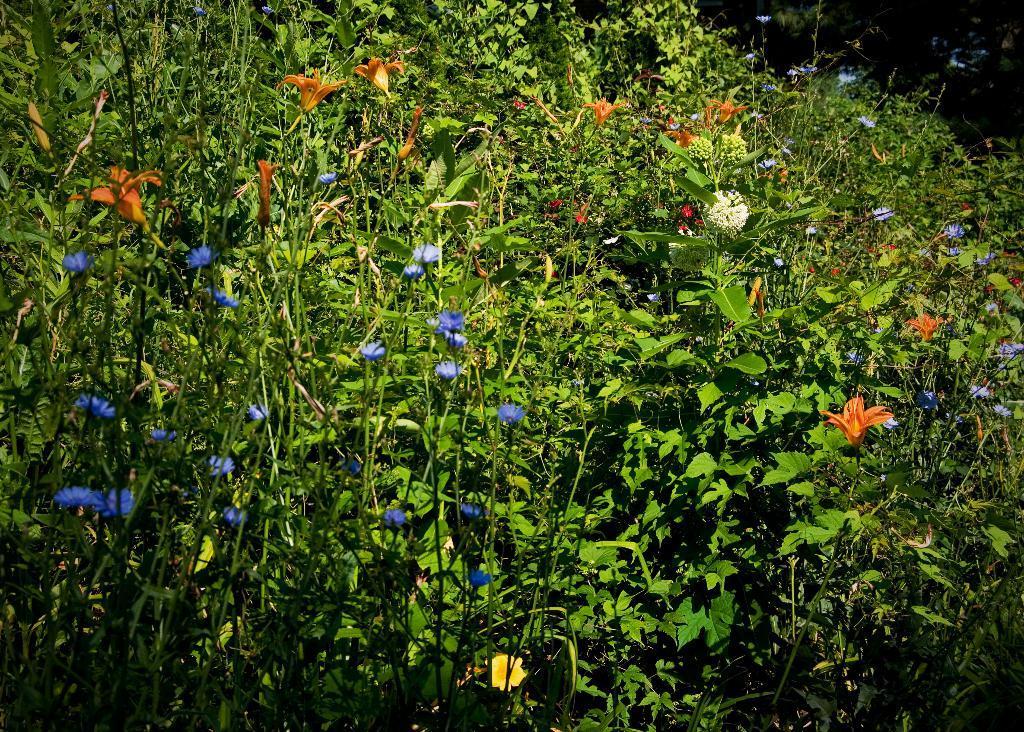Can you describe this image briefly? In the image we can see some plants and flowers. 